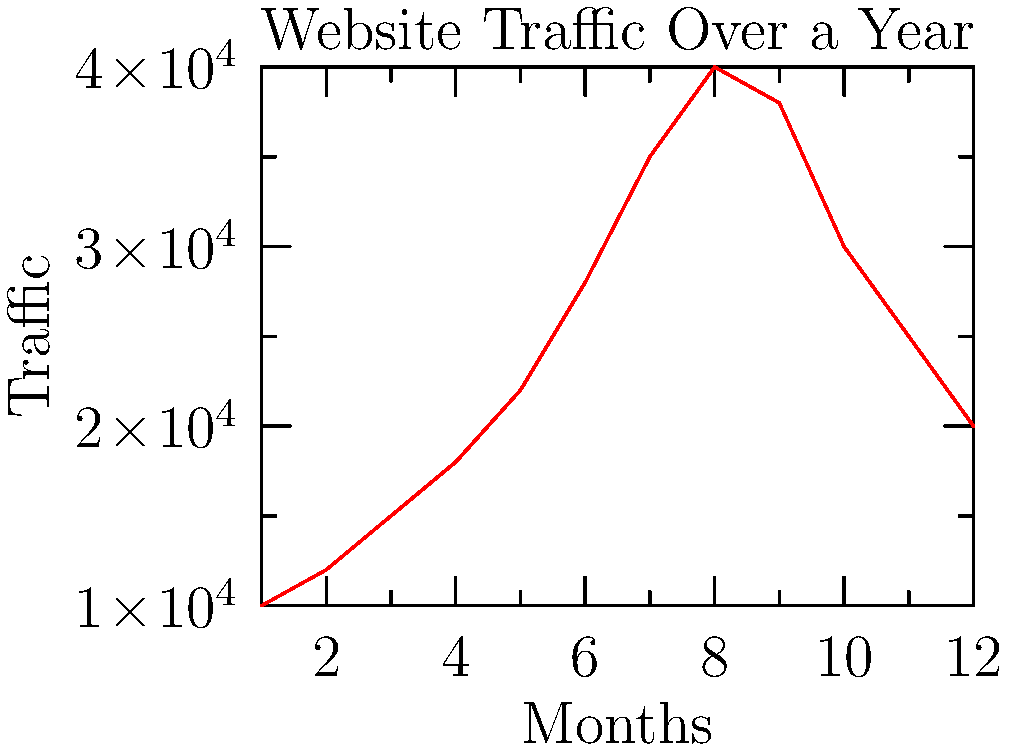Analyze the website traffic graph over a year. What is the most likely explanation for the traffic pattern observed? Let's analyze the graph step-by-step:

1. The graph shows website traffic over 12 months (likely representing a full year).
2. Traffic starts low in month 1 (possibly January) at around 10,000 visits.
3. There's a steady increase in traffic from months 1 to 8.
4. The peak occurs in month 8 (possibly August) with about 40,000 visits.
5. After month 8, there's a gradual decline until month 12.

This pattern is typical for genealogy websites, which often experience:
- Increased traffic during summer months when people have more free time for family history research.
- Peak traffic in late summer (August) when many families gather for reunions and share family history information.
- Decreased traffic in fall and winter as people become busier with work, school, and holidays.

The gradual increase and decrease suggest a seasonal pattern rather than sudden events or technical issues.
Answer: Seasonal traffic pattern with summer peak 